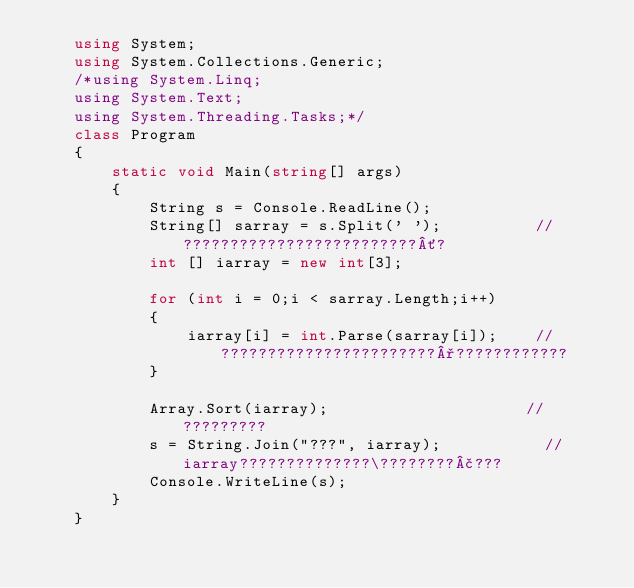Convert code to text. <code><loc_0><loc_0><loc_500><loc_500><_C#_>    using System;
    using System.Collections.Generic;
    /*using System.Linq;
    using System.Text;
    using System.Threading.Tasks;*/
    class Program
    {
        static void Main(string[] args)
        {
            String s = Console.ReadLine();
            String[] sarray = s.Split(' ');          //?????????????????????????´?
            int [] iarray = new int[3];

            for (int i = 0;i < sarray.Length;i++)
            {
                iarray[i] = int.Parse(sarray[i]);    //???????????????????????°????????????
            }

            Array.Sort(iarray);                     //?????????
            s = String.Join("???", iarray);           //iarray??????????????\????????£???
            Console.WriteLine(s);
        }
    }</code> 